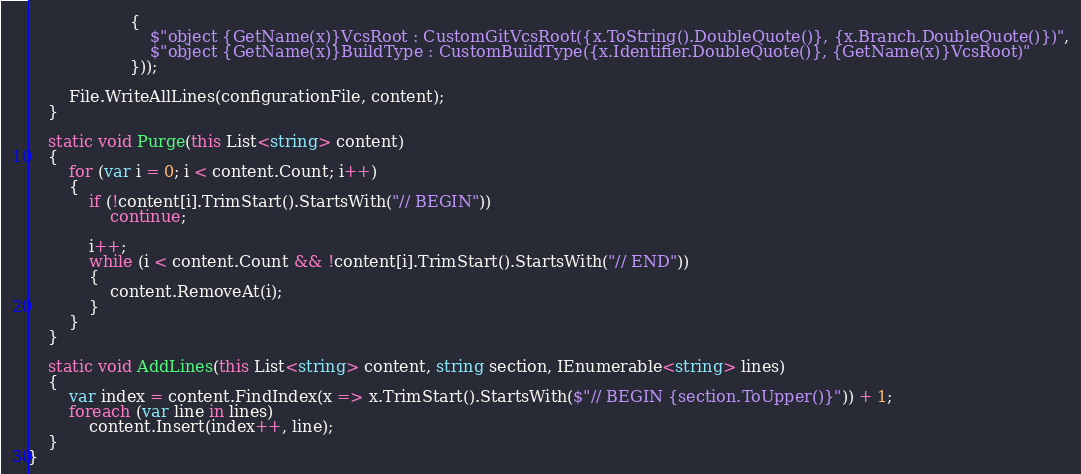<code> <loc_0><loc_0><loc_500><loc_500><_C#_>                    {
                        $"object {GetName(x)}VcsRoot : CustomGitVcsRoot({x.ToString().DoubleQuote()}, {x.Branch.DoubleQuote()})",
                        $"object {GetName(x)}BuildType : CustomBuildType({x.Identifier.DoubleQuote()}, {GetName(x)}VcsRoot)"
                    }));

        File.WriteAllLines(configurationFile, content);
    }

    static void Purge(this List<string> content)
    {
        for (var i = 0; i < content.Count; i++)
        {
            if (!content[i].TrimStart().StartsWith("// BEGIN"))
                continue;

            i++;
            while (i < content.Count && !content[i].TrimStart().StartsWith("// END"))
            {
                content.RemoveAt(i);
            }
        }
    }

    static void AddLines(this List<string> content, string section, IEnumerable<string> lines)
    {
        var index = content.FindIndex(x => x.TrimStart().StartsWith($"// BEGIN {section.ToUpper()}")) + 1;
        foreach (var line in lines)
            content.Insert(index++, line);
    }
}</code> 